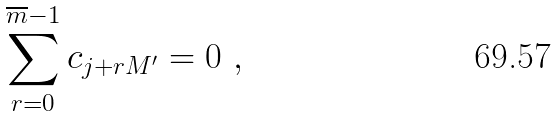Convert formula to latex. <formula><loc_0><loc_0><loc_500><loc_500>\sum _ { r = 0 } ^ { \overline { m } - 1 } c _ { j + r M ^ { \prime } } = 0 \ ,</formula> 